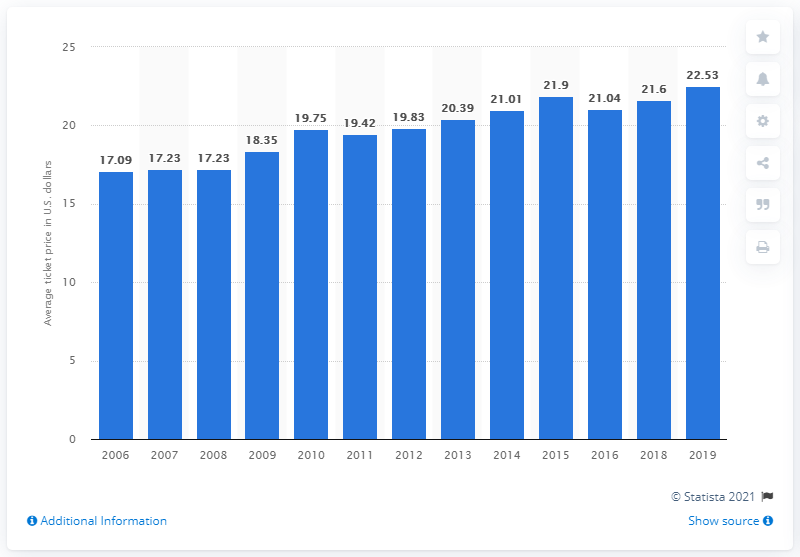Draw attention to some important aspects in this diagram. The average ticket price for Tampa Bay Rays games in 2019 was $22.53. 